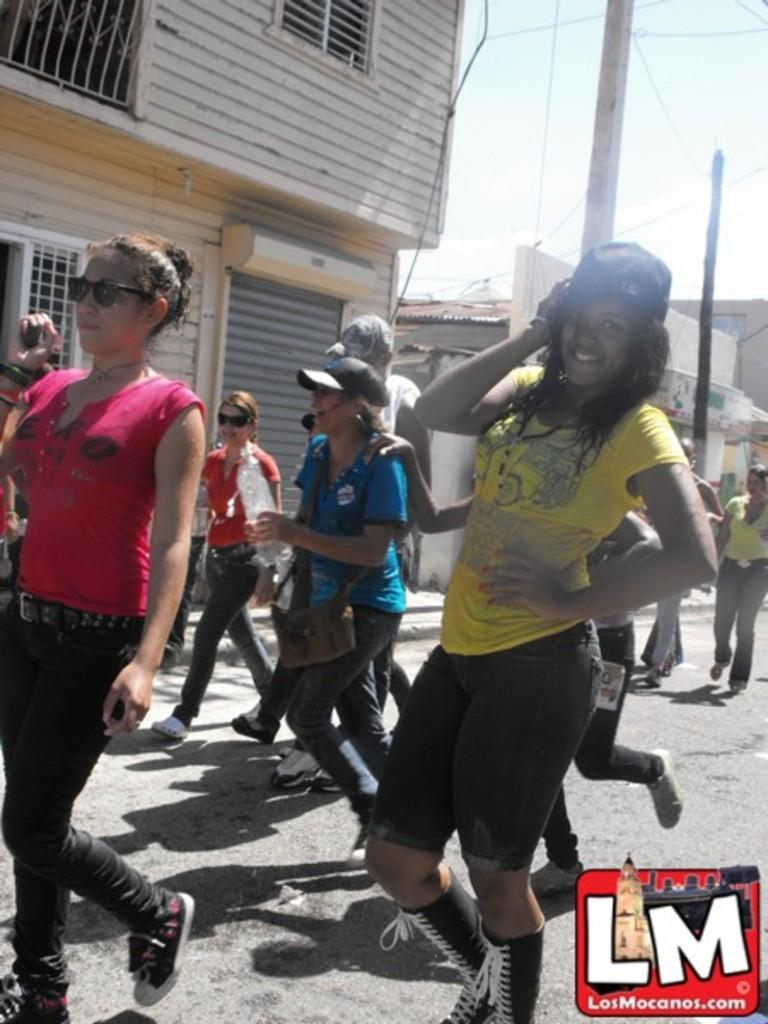What are the persons in the image doing? The persons in the image are walking. Can you describe the woman's expression in the image? The woman is smiling in the image. What color is the woman's t-shirt in the image? The woman is wearing a yellow t-shirt. What can be seen in the background of the image? There are buildings and poles in the background of the image. How would you describe the weather in the image? The sky is cloudy in the image. What type of corn is being discovered by the persons in the image? There is no corn present in the image, and no discovery is taking place. 